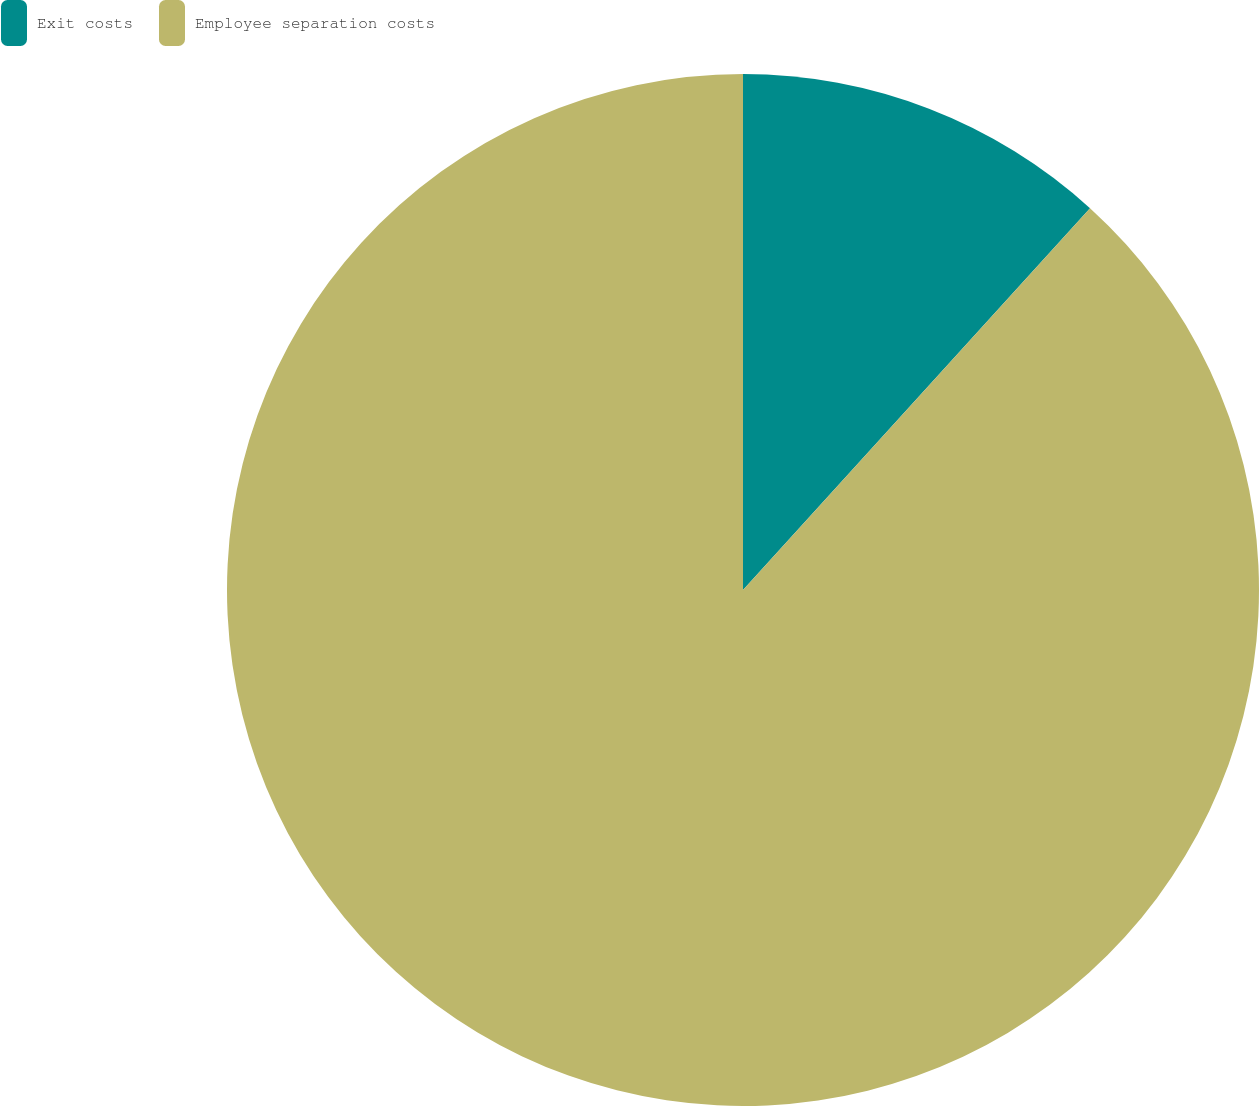<chart> <loc_0><loc_0><loc_500><loc_500><pie_chart><fcel>Exit costs<fcel>Employee separation costs<nl><fcel>11.74%<fcel>88.26%<nl></chart> 